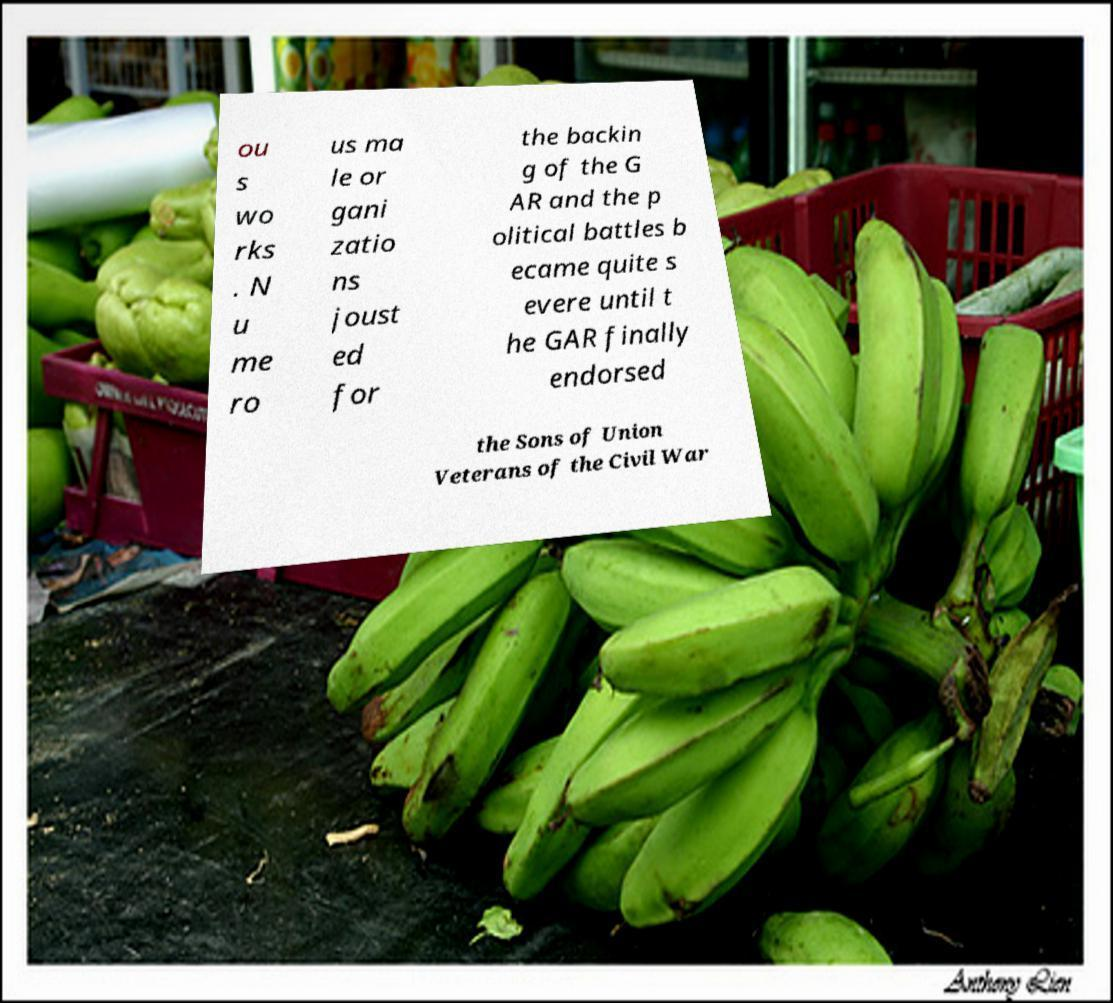Can you read and provide the text displayed in the image?This photo seems to have some interesting text. Can you extract and type it out for me? ou s wo rks . N u me ro us ma le or gani zatio ns joust ed for the backin g of the G AR and the p olitical battles b ecame quite s evere until t he GAR finally endorsed the Sons of Union Veterans of the Civil War 